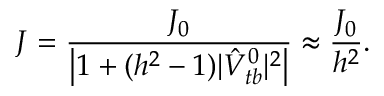<formula> <loc_0><loc_0><loc_500><loc_500>J = \frac { J _ { 0 } } { \left | 1 + ( h ^ { 2 } - 1 ) | \hat { V } _ { t b } ^ { 0 } | ^ { 2 } \right | } \approx \frac { J _ { 0 } } { h ^ { 2 } } .</formula> 